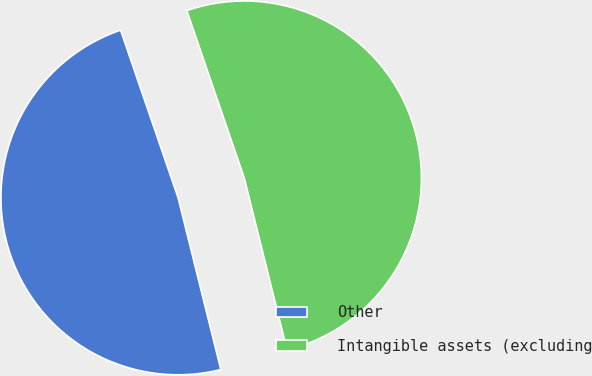Convert chart. <chart><loc_0><loc_0><loc_500><loc_500><pie_chart><fcel>Other<fcel>Intangible assets (excluding<nl><fcel>48.62%<fcel>51.38%<nl></chart> 